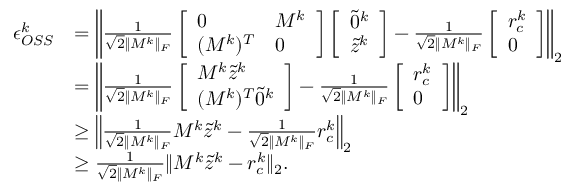<formula> <loc_0><loc_0><loc_500><loc_500>\begin{array} { r l } { \epsilon _ { O S S } ^ { k } } & { = \left \| \frac { 1 } { \sqrt { 2 } \| M ^ { k } \| _ { F } } \left [ \begin{array} { l l } { 0 } & { M ^ { k } } \\ { ( M ^ { k } ) ^ { T } } & { 0 } \end{array} \right ] \left [ \begin{array} { l } { \tilde { 0 } ^ { k } } \\ { \tilde { z } ^ { k } } \end{array} \right ] - \frac { 1 } { \sqrt { 2 } \| M ^ { k } \| _ { F } } \left [ \begin{array} { l } { r _ { c } ^ { k } } \\ { 0 } \end{array} \right ] \right \| _ { 2 } } \\ & { = \left \| \frac { 1 } { \sqrt { 2 } \| M ^ { k } \| _ { F } } \left [ \begin{array} { l } { M ^ { k } \tilde { z } ^ { k } } \\ { ( M ^ { k } ) ^ { T } \tilde { 0 } ^ { k } } \end{array} \right ] - \frac { 1 } { \sqrt { 2 } \| M ^ { k } \| _ { F } } \left [ \begin{array} { l } { r _ { c } ^ { k } } \\ { 0 } \end{array} \right ] \right \| _ { 2 } } \\ & { \geq \left \| \frac { 1 } { \sqrt { 2 } \| M ^ { k } \| _ { F } } M ^ { k } \tilde { z } ^ { k } - \frac { 1 } { \sqrt { 2 } \| M ^ { k } \| _ { F } } r _ { c } ^ { k } \right \| _ { 2 } } \\ & { \geq \frac { 1 } { \sqrt { 2 } \| M ^ { k } \| _ { F } } \| M ^ { k } \tilde { z } ^ { k } - r _ { c } ^ { k } \| _ { 2 } . } \end{array}</formula> 